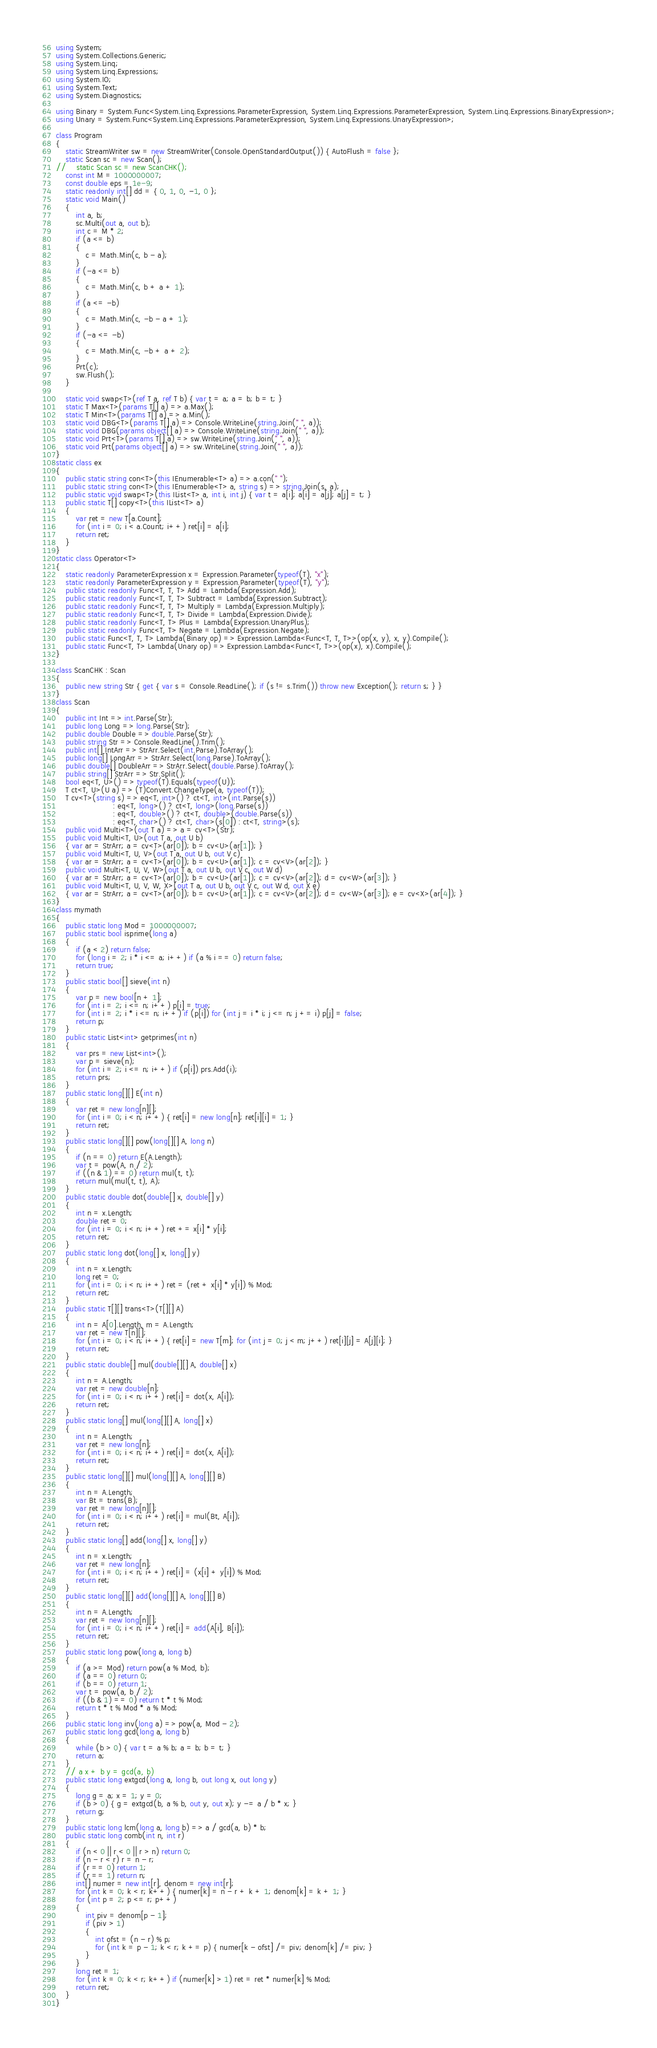<code> <loc_0><loc_0><loc_500><loc_500><_C#_>using System;
using System.Collections.Generic;
using System.Linq;
using System.Linq.Expressions;
using System.IO;
using System.Text;
using System.Diagnostics;

using Binary = System.Func<System.Linq.Expressions.ParameterExpression, System.Linq.Expressions.ParameterExpression, System.Linq.Expressions.BinaryExpression>;
using Unary = System.Func<System.Linq.Expressions.ParameterExpression, System.Linq.Expressions.UnaryExpression>;

class Program
{
    static StreamWriter sw = new StreamWriter(Console.OpenStandardOutput()) { AutoFlush = false };
    static Scan sc = new Scan();
//    static Scan sc = new ScanCHK();
    const int M = 1000000007;
    const double eps = 1e-9;
    static readonly int[] dd = { 0, 1, 0, -1, 0 };
    static void Main()
    {
        int a, b;
        sc.Multi(out a, out b);
        int c = M * 2;
        if (a <= b)
        {
            c = Math.Min(c, b - a);
        }
        if (-a <= b)
        {
            c = Math.Min(c, b + a + 1);
        }
        if (a <= -b)
        {
            c = Math.Min(c, -b - a + 1);
        }
        if (-a <= -b)
        {
            c = Math.Min(c, -b + a + 2);
        }
        Prt(c);
        sw.Flush();
    }

    static void swap<T>(ref T a, ref T b) { var t = a; a = b; b = t; }
    static T Max<T>(params T[] a) => a.Max();
    static T Min<T>(params T[] a) => a.Min();
    static void DBG<T>(params T[] a) => Console.WriteLine(string.Join(" ", a));
    static void DBG(params object[] a) => Console.WriteLine(string.Join(" ", a));
    static void Prt<T>(params T[] a) => sw.WriteLine(string.Join(" ", a));
    static void Prt(params object[] a) => sw.WriteLine(string.Join(" ", a));
}
static class ex
{
    public static string con<T>(this IEnumerable<T> a) => a.con(" ");
    public static string con<T>(this IEnumerable<T> a, string s) => string.Join(s, a);
    public static void swap<T>(this IList<T> a, int i, int j) { var t = a[i]; a[i] = a[j]; a[j] = t; }
    public static T[] copy<T>(this IList<T> a)
    {
        var ret = new T[a.Count];
        for (int i = 0; i < a.Count; i++) ret[i] = a[i];
        return ret;
    }
}
static class Operator<T>
{
    static readonly ParameterExpression x = Expression.Parameter(typeof(T), "x");
    static readonly ParameterExpression y = Expression.Parameter(typeof(T), "y");
    public static readonly Func<T, T, T> Add = Lambda(Expression.Add);
    public static readonly Func<T, T, T> Subtract = Lambda(Expression.Subtract);
    public static readonly Func<T, T, T> Multiply = Lambda(Expression.Multiply);
    public static readonly Func<T, T, T> Divide = Lambda(Expression.Divide);
    public static readonly Func<T, T> Plus = Lambda(Expression.UnaryPlus);
    public static readonly Func<T, T> Negate = Lambda(Expression.Negate);
    public static Func<T, T, T> Lambda(Binary op) => Expression.Lambda<Func<T, T, T>>(op(x, y), x, y).Compile();
    public static Func<T, T> Lambda(Unary op) => Expression.Lambda<Func<T, T>>(op(x), x).Compile();
}

class ScanCHK : Scan
{
    public new string Str { get { var s = Console.ReadLine(); if (s != s.Trim()) throw new Exception(); return s; } }
}
class Scan
{
    public int Int => int.Parse(Str);
    public long Long => long.Parse(Str);
    public double Double => double.Parse(Str);
    public string Str => Console.ReadLine().Trim();
    public int[] IntArr => StrArr.Select(int.Parse).ToArray();
    public long[] LongArr => StrArr.Select(long.Parse).ToArray();
    public double[] DoubleArr => StrArr.Select(double.Parse).ToArray();
    public string[] StrArr => Str.Split();
    bool eq<T, U>() => typeof(T).Equals(typeof(U));
    T ct<T, U>(U a) => (T)Convert.ChangeType(a, typeof(T));
    T cv<T>(string s) => eq<T, int>() ? ct<T, int>(int.Parse(s))
                       : eq<T, long>() ? ct<T, long>(long.Parse(s))
                       : eq<T, double>() ? ct<T, double>(double.Parse(s))
                       : eq<T, char>() ? ct<T, char>(s[0]) : ct<T, string>(s);
    public void Multi<T>(out T a) => a = cv<T>(Str);
    public void Multi<T, U>(out T a, out U b)
    { var ar = StrArr; a = cv<T>(ar[0]); b = cv<U>(ar[1]); }
    public void Multi<T, U, V>(out T a, out U b, out V c)
    { var ar = StrArr; a = cv<T>(ar[0]); b = cv<U>(ar[1]); c = cv<V>(ar[2]); }
    public void Multi<T, U, V, W>(out T a, out U b, out V c, out W d)
    { var ar = StrArr; a = cv<T>(ar[0]); b = cv<U>(ar[1]); c = cv<V>(ar[2]); d = cv<W>(ar[3]); }
    public void Multi<T, U, V, W, X>(out T a, out U b, out V c, out W d, out X e)
    { var ar = StrArr; a = cv<T>(ar[0]); b = cv<U>(ar[1]); c = cv<V>(ar[2]); d = cv<W>(ar[3]); e = cv<X>(ar[4]); }
}
class mymath
{
    public static long Mod = 1000000007;
    public static bool isprime(long a)
    {
        if (a < 2) return false;
        for (long i = 2; i * i <= a; i++) if (a % i == 0) return false;
        return true;
    }
    public static bool[] sieve(int n)
    {
        var p = new bool[n + 1];
        for (int i = 2; i <= n; i++) p[i] = true;
        for (int i = 2; i * i <= n; i++) if (p[i]) for (int j = i * i; j <= n; j += i) p[j] = false;
        return p;
    }
    public static List<int> getprimes(int n)
    {
        var prs = new List<int>();
        var p = sieve(n);
        for (int i = 2; i <= n; i++) if (p[i]) prs.Add(i);
        return prs;
    }
    public static long[][] E(int n)
    {
        var ret = new long[n][];
        for (int i = 0; i < n; i++) { ret[i] = new long[n]; ret[i][i] = 1; }
        return ret;
    }
    public static long[][] pow(long[][] A, long n)
    {
        if (n == 0) return E(A.Length);
        var t = pow(A, n / 2);
        if ((n & 1) == 0) return mul(t, t);
        return mul(mul(t, t), A);
    }
    public static double dot(double[] x, double[] y)
    {
        int n = x.Length;
        double ret = 0;
        for (int i = 0; i < n; i++) ret += x[i] * y[i];
        return ret;
    }
    public static long dot(long[] x, long[] y)
    {
        int n = x.Length;
        long ret = 0;
        for (int i = 0; i < n; i++) ret = (ret + x[i] * y[i]) % Mod;
        return ret;
    }
    public static T[][] trans<T>(T[][] A)
    {
        int n = A[0].Length, m = A.Length;
        var ret = new T[n][];
        for (int i = 0; i < n; i++) { ret[i] = new T[m]; for (int j = 0; j < m; j++) ret[i][j] = A[j][i]; }
        return ret;
    }
    public static double[] mul(double[][] A, double[] x)
    {
        int n = A.Length;
        var ret = new double[n];
        for (int i = 0; i < n; i++) ret[i] = dot(x, A[i]);
        return ret;
    }
    public static long[] mul(long[][] A, long[] x)
    {
        int n = A.Length;
        var ret = new long[n];
        for (int i = 0; i < n; i++) ret[i] = dot(x, A[i]);
        return ret;
    }
    public static long[][] mul(long[][] A, long[][] B)
    {
        int n = A.Length;
        var Bt = trans(B);
        var ret = new long[n][];
        for (int i = 0; i < n; i++) ret[i] = mul(Bt, A[i]);
        return ret;
    }
    public static long[] add(long[] x, long[] y)
    {
        int n = x.Length;
        var ret = new long[n];
        for (int i = 0; i < n; i++) ret[i] = (x[i] + y[i]) % Mod;
        return ret;
    }
    public static long[][] add(long[][] A, long[][] B)
    {
        int n = A.Length;
        var ret = new long[n][];
        for (int i = 0; i < n; i++) ret[i] = add(A[i], B[i]);
        return ret;
    }
    public static long pow(long a, long b)
    {
        if (a >= Mod) return pow(a % Mod, b);
        if (a == 0) return 0;
        if (b == 0) return 1;
        var t = pow(a, b / 2);
        if ((b & 1) == 0) return t * t % Mod;
        return t * t % Mod * a % Mod;
    }
    public static long inv(long a) => pow(a, Mod - 2);
    public static long gcd(long a, long b)
    {
        while (b > 0) { var t = a % b; a = b; b = t; }
        return a;
    }
    // a x + b y = gcd(a, b)
    public static long extgcd(long a, long b, out long x, out long y)
    {
        long g = a; x = 1; y = 0;
        if (b > 0) { g = extgcd(b, a % b, out y, out x); y -= a / b * x; }
        return g;
    }
    public static long lcm(long a, long b) => a / gcd(a, b) * b;
    public static long comb(int n, int r)
    {
        if (n < 0 || r < 0 || r > n) return 0;
        if (n - r < r) r = n - r;
        if (r == 0) return 1;
        if (r == 1) return n;
        int[] numer = new int[r], denom = new int[r];
        for (int k = 0; k < r; k++) { numer[k] = n - r + k + 1; denom[k] = k + 1; }
        for (int p = 2; p <= r; p++)
        {
            int piv = denom[p - 1];
            if (piv > 1)
            {
                int ofst = (n - r) % p;
                for (int k = p - 1; k < r; k += p) { numer[k - ofst] /= piv; denom[k] /= piv; }
            }
        }
        long ret = 1;
        for (int k = 0; k < r; k++) if (numer[k] > 1) ret = ret * numer[k] % Mod;
        return ret;
    }
}
</code> 